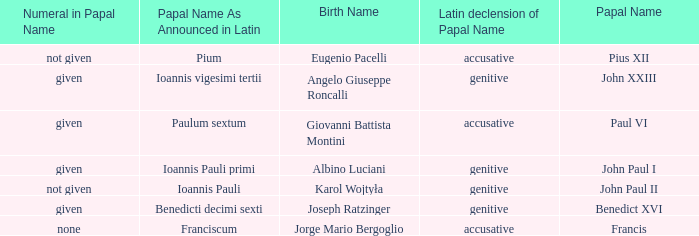Give me the full table as a dictionary. {'header': ['Numeral in Papal Name', 'Papal Name As Announced in Latin', 'Birth Name', 'Latin declension of Papal Name', 'Papal Name'], 'rows': [['not given', 'Pium', 'Eugenio Pacelli', 'accusative', 'Pius XII'], ['given', 'Ioannis vigesimi tertii', 'Angelo Giuseppe Roncalli', 'genitive', 'John XXIII'], ['given', 'Paulum sextum', 'Giovanni Battista Montini', 'accusative', 'Paul VI'], ['given', 'Ioannis Pauli primi', 'Albino Luciani', 'genitive', 'John Paul I'], ['not given', 'Ioannis Pauli', 'Karol Wojtyła', 'genitive', 'John Paul II'], ['given', 'Benedicti decimi sexti', 'Joseph Ratzinger', 'genitive', 'Benedict XVI'], ['none', 'Franciscum', 'Jorge Mario Bergoglio', 'accusative', 'Francis']]} For the pope born Eugenio Pacelli, what is the declension of his papal name? Accusative. 